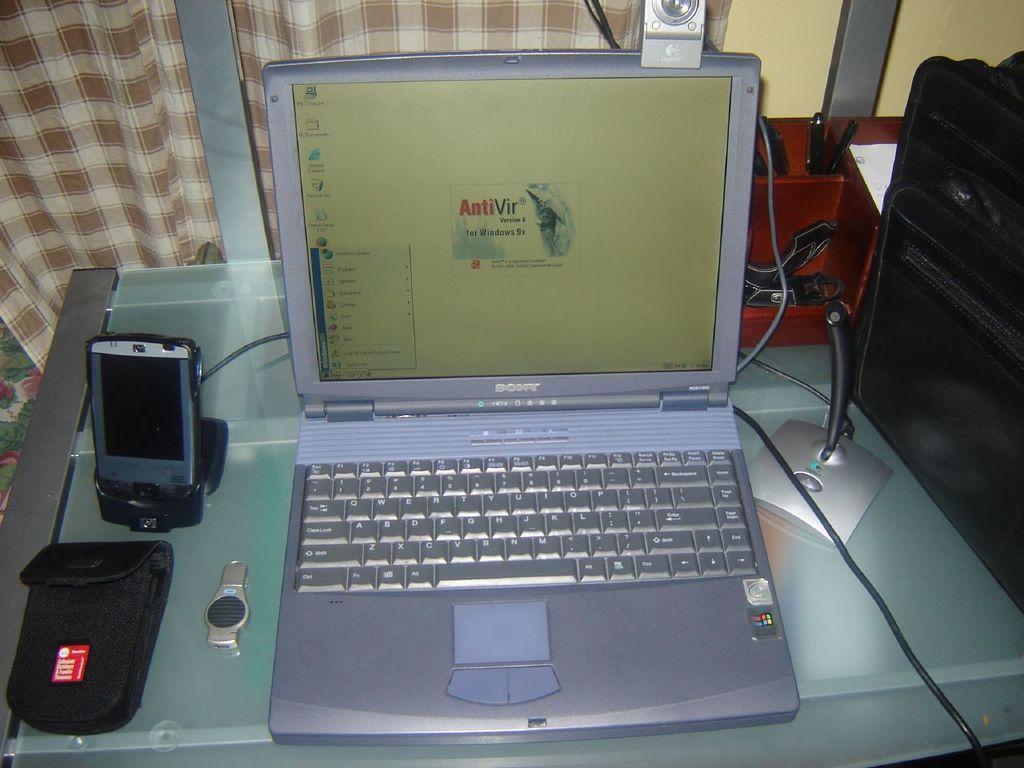What brand is the laptop?
Ensure brevity in your answer.  Sony. Sony laptop brand?
Provide a short and direct response. Yes. 